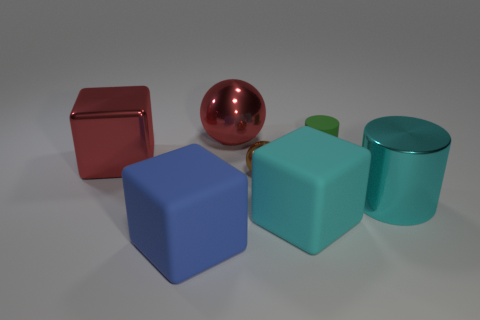Add 3 large matte cubes. How many objects exist? 10 Subtract all spheres. How many objects are left? 5 Add 1 small brown things. How many small brown things are left? 2 Add 1 tiny green spheres. How many tiny green spheres exist? 1 Subtract 0 blue cylinders. How many objects are left? 7 Subtract all large cyan rubber cubes. Subtract all tiny objects. How many objects are left? 4 